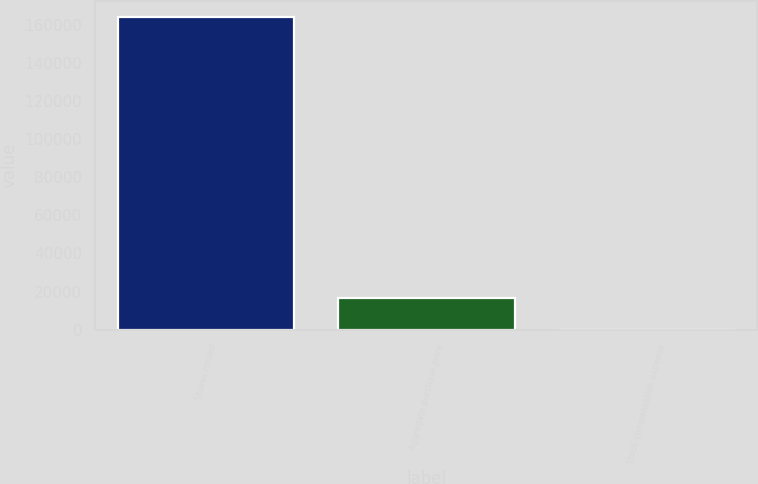Convert chart. <chart><loc_0><loc_0><loc_500><loc_500><bar_chart><fcel>Shares issued<fcel>Aggregate purchase price<fcel>Stock compensation expense<nl><fcel>164000<fcel>16400.5<fcel>0.6<nl></chart> 